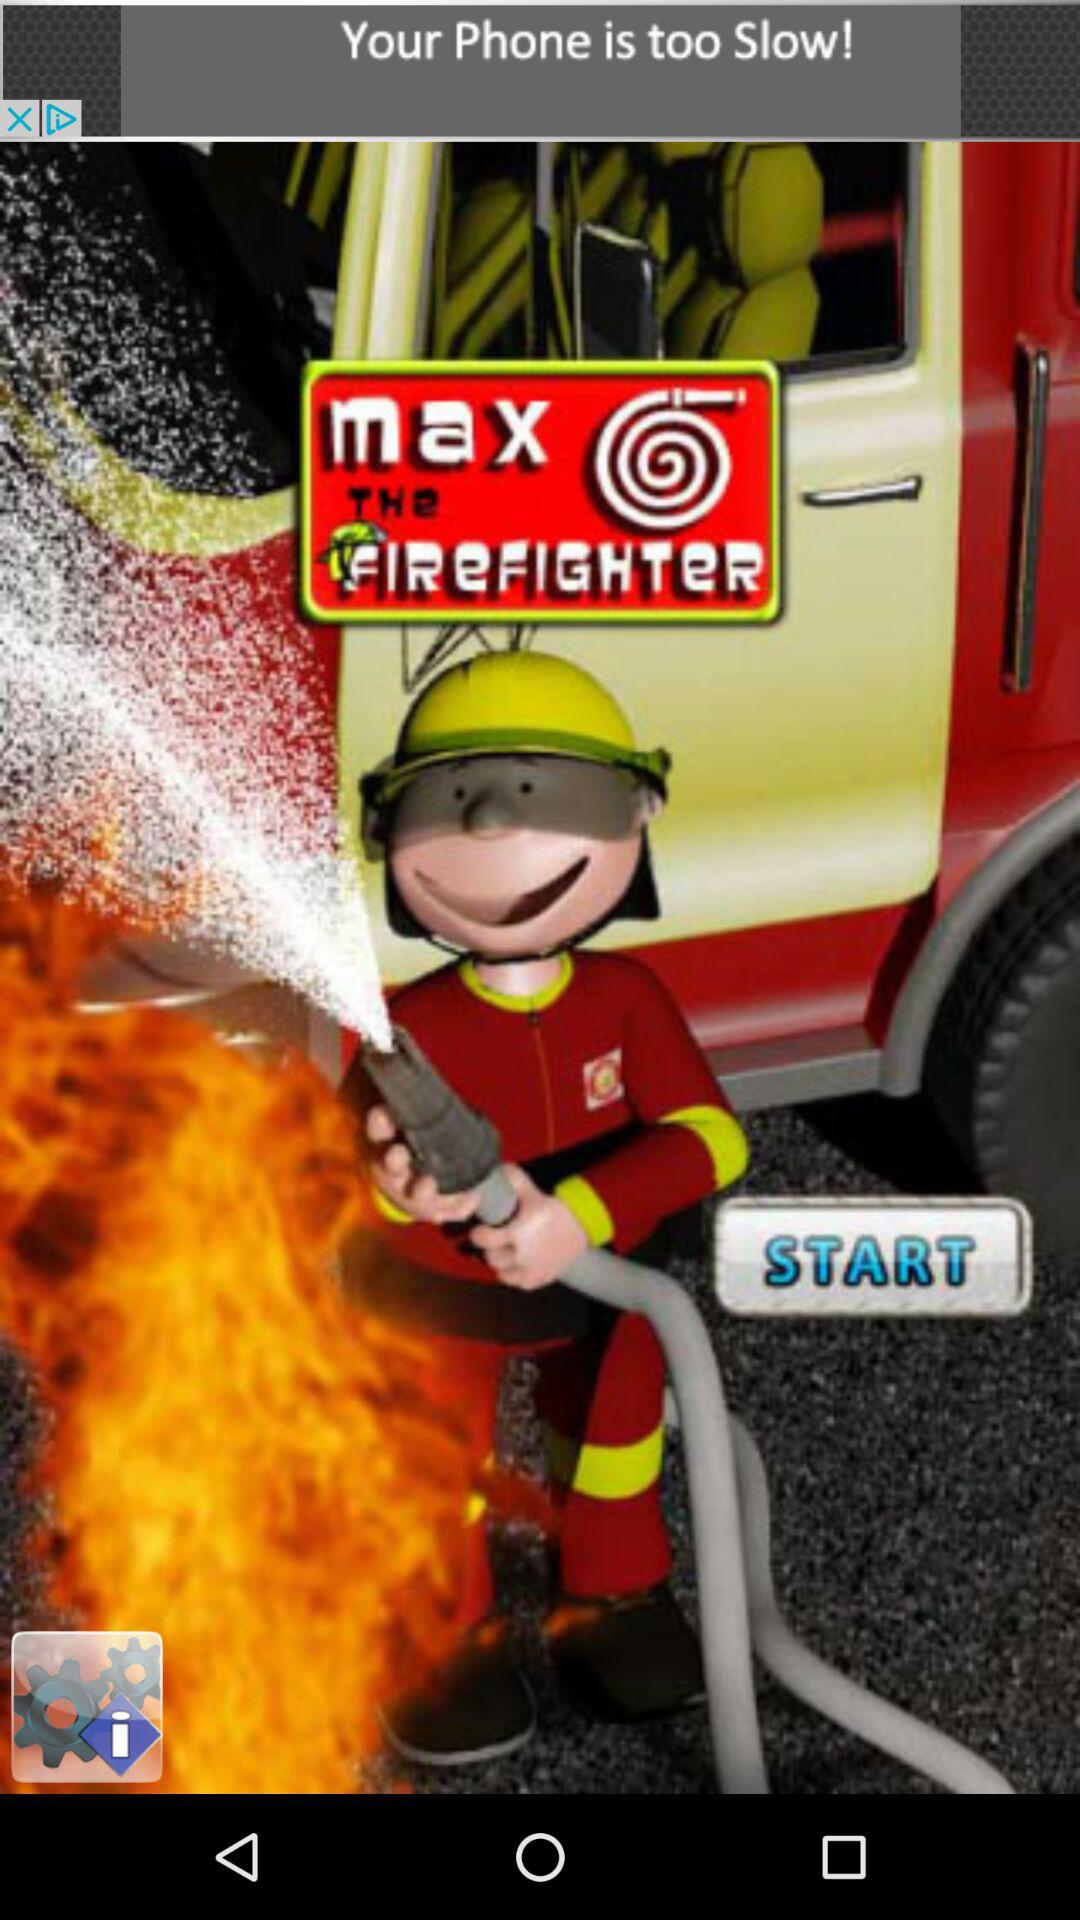What is the name of the application? The name of the application is "Max The Firefighter". 